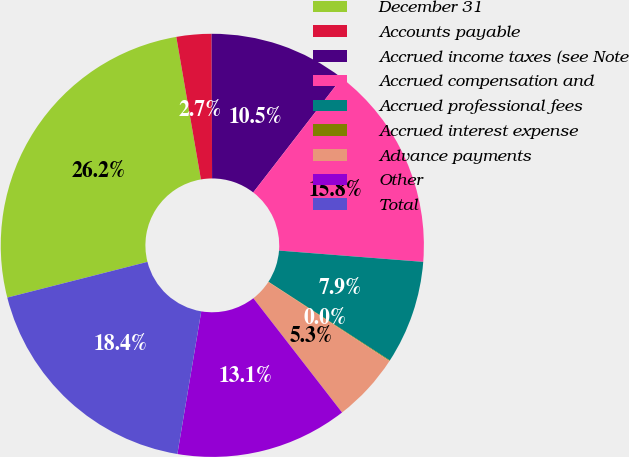<chart> <loc_0><loc_0><loc_500><loc_500><pie_chart><fcel>December 31<fcel>Accounts payable<fcel>Accrued income taxes (see Note<fcel>Accrued compensation and<fcel>Accrued professional fees<fcel>Accrued interest expense<fcel>Advance payments<fcel>Other<fcel>Total<nl><fcel>26.25%<fcel>2.67%<fcel>10.53%<fcel>15.77%<fcel>7.91%<fcel>0.05%<fcel>5.29%<fcel>13.15%<fcel>18.39%<nl></chart> 